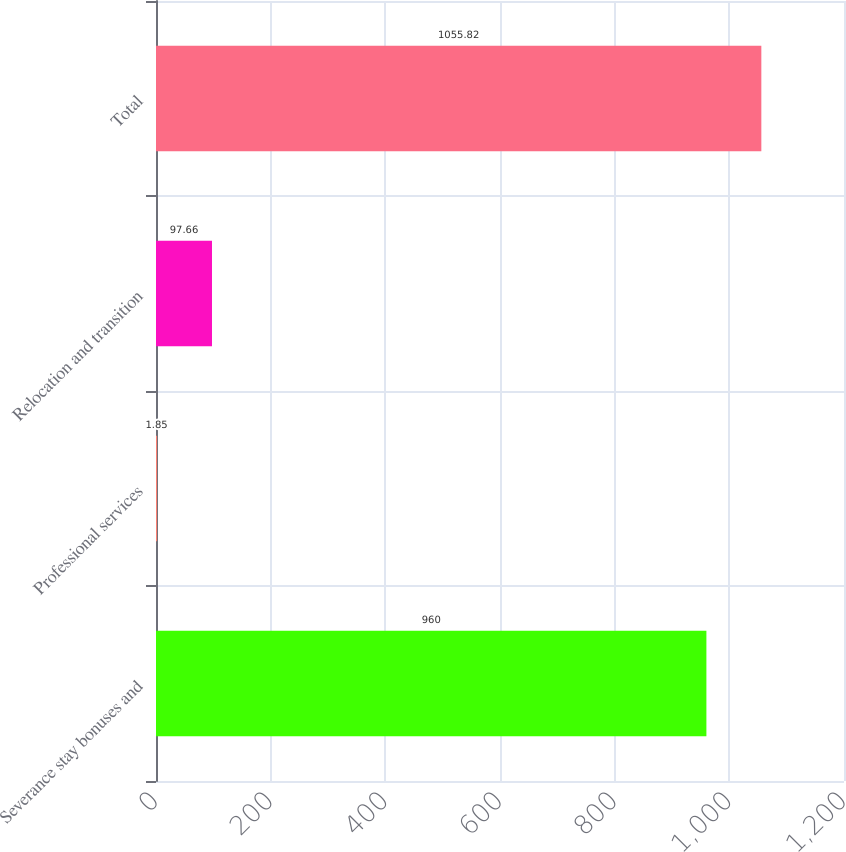Convert chart to OTSL. <chart><loc_0><loc_0><loc_500><loc_500><bar_chart><fcel>Severance stay bonuses and<fcel>Professional services<fcel>Relocation and transition<fcel>Total<nl><fcel>960<fcel>1.85<fcel>97.66<fcel>1055.82<nl></chart> 